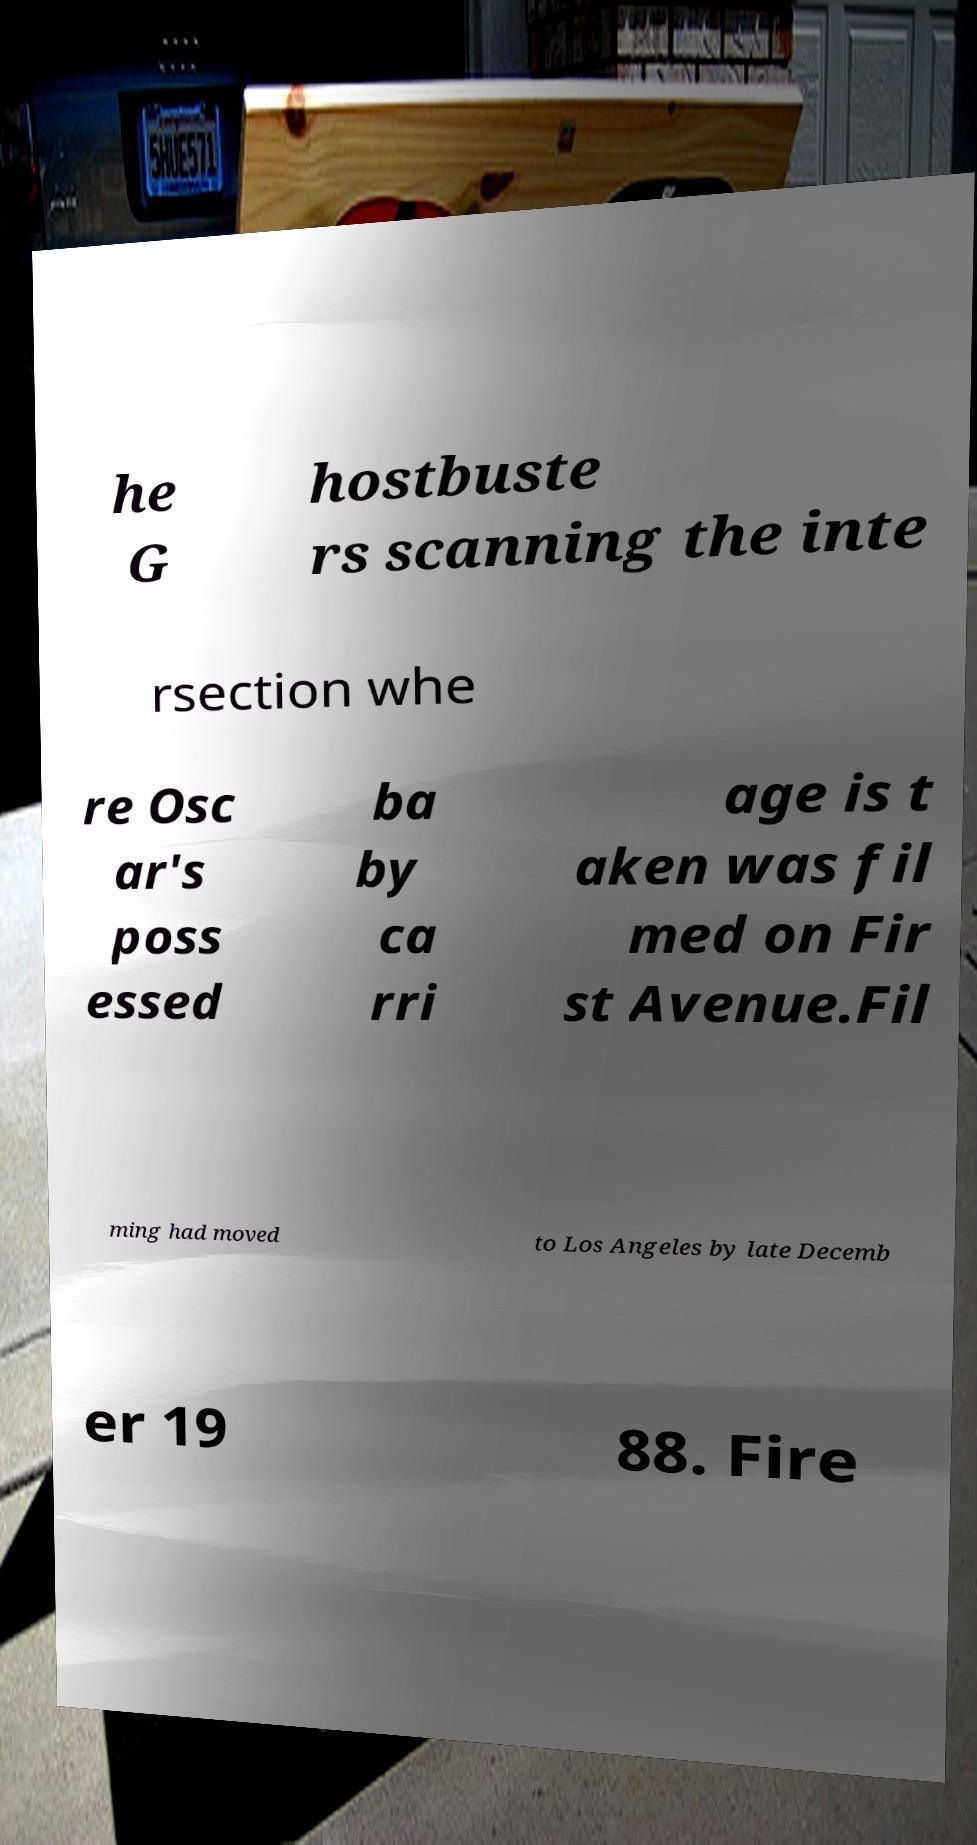Could you extract and type out the text from this image? he G hostbuste rs scanning the inte rsection whe re Osc ar's poss essed ba by ca rri age is t aken was fil med on Fir st Avenue.Fil ming had moved to Los Angeles by late Decemb er 19 88. Fire 